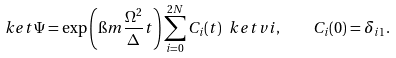Convert formula to latex. <formula><loc_0><loc_0><loc_500><loc_500>\ k e t { \Psi } = \exp \left ( \i m \frac { \Omega ^ { 2 } } { \Delta } t \right ) \sum _ { i = 0 } ^ { 2 N } C _ { i } ( t ) \ k e t v { i } , \quad C _ { i } ( 0 ) = \delta _ { i 1 } .</formula> 